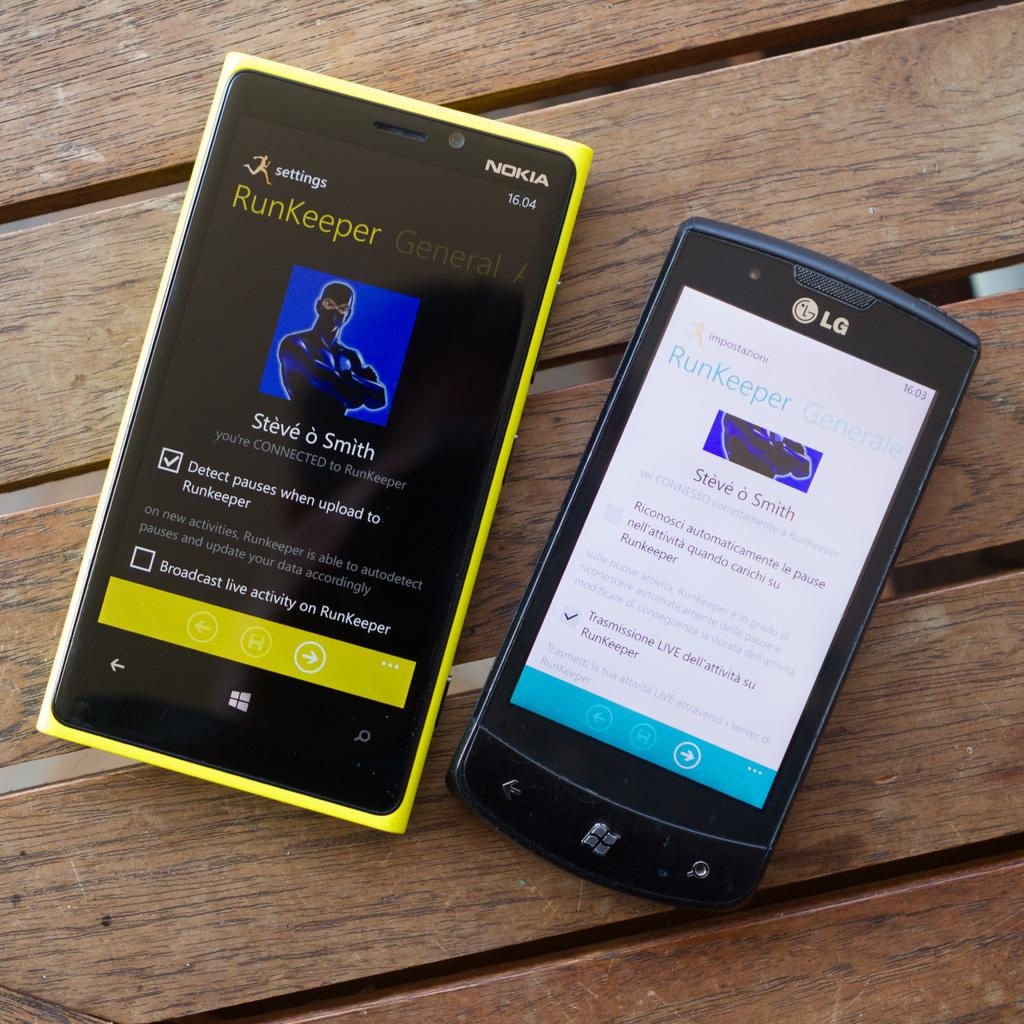<image>
Create a compact narrative representing the image presented. An LG phone displays the RunKeeper app in non English language. 